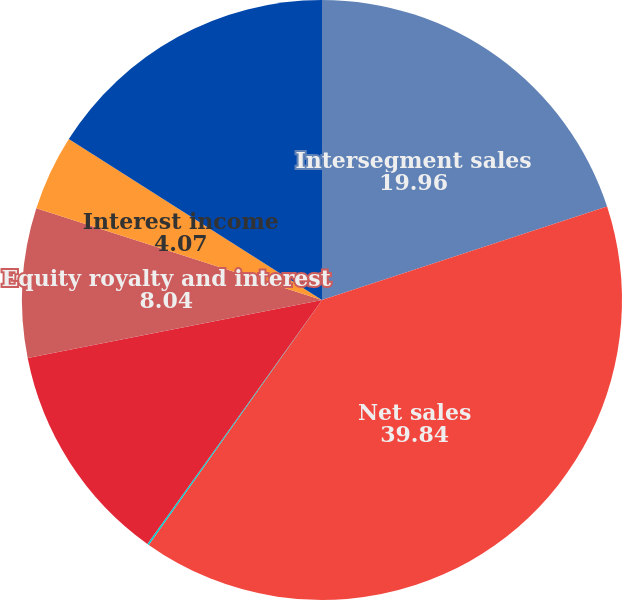Convert chart. <chart><loc_0><loc_0><loc_500><loc_500><pie_chart><fcel>Intersegment sales<fcel>Net sales<fcel>Depreciation and amortization<fcel>Research development and<fcel>Equity royalty and interest<fcel>Interest income<fcel>Segment EBIT<nl><fcel>19.96%<fcel>39.84%<fcel>0.09%<fcel>12.01%<fcel>8.04%<fcel>4.07%<fcel>15.99%<nl></chart> 